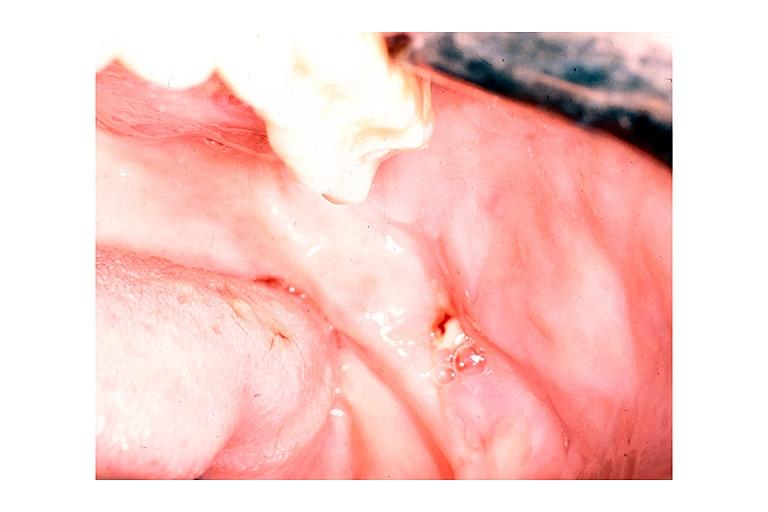s hematologic present?
Answer the question using a single word or phrase. No 